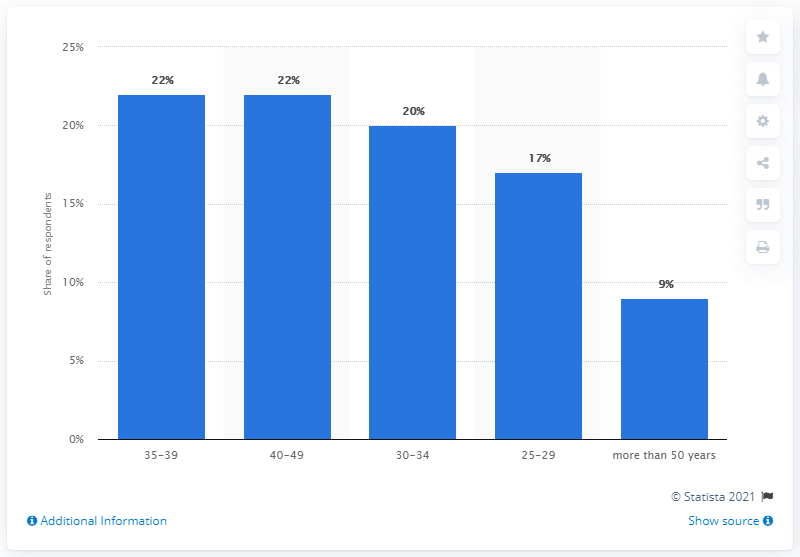Highlight a few significant elements in this photo. According to the data, 22% of game developers fall within the age range of 35 to 39 and 40 to 49 years old. 